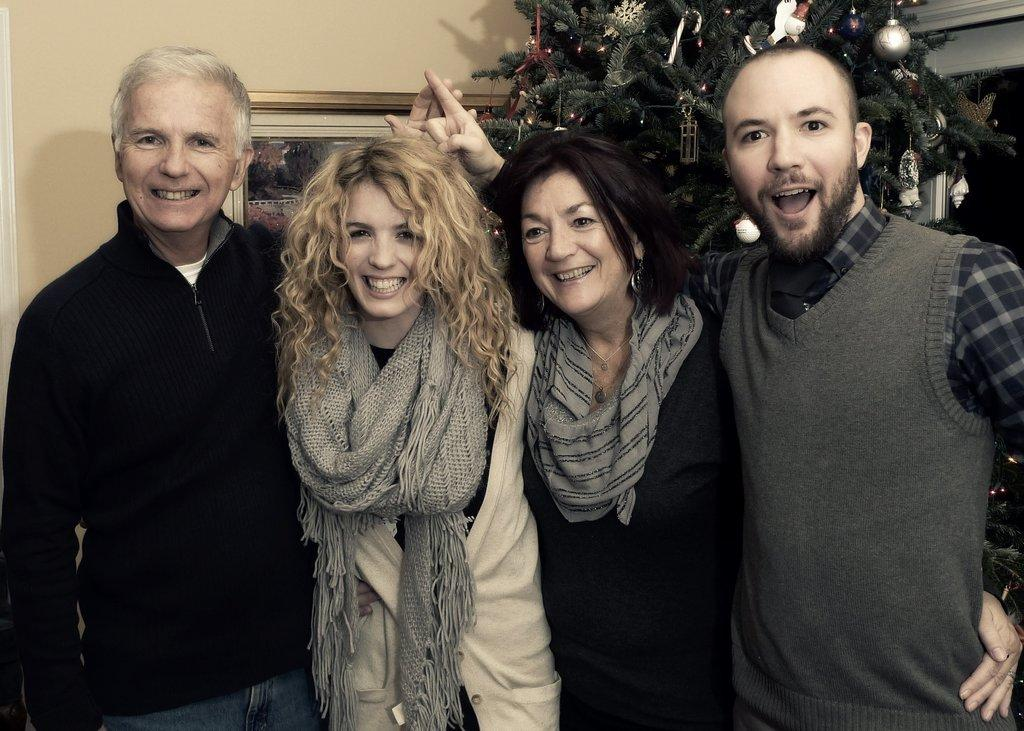How many people are present in the image? There are two women and two men standing in the image. What can be seen in the background of the image? There is a Christmas tree and a wall with a photo frame in the background of the image. What type of quartz is visible on the wall in the image? There is no quartz present in the image; the wall has a photo frame. 